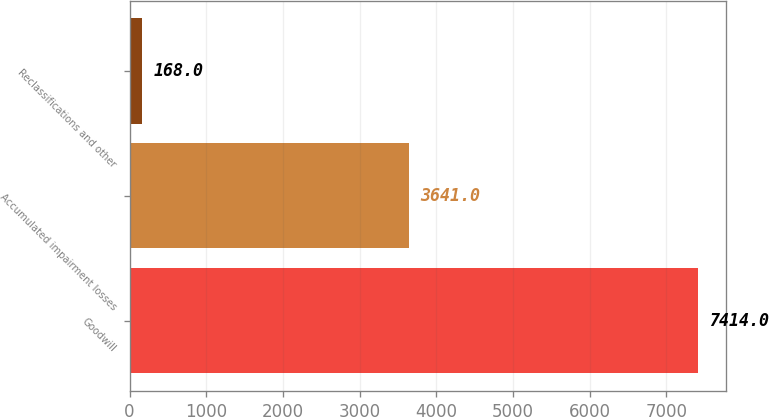Convert chart to OTSL. <chart><loc_0><loc_0><loc_500><loc_500><bar_chart><fcel>Goodwill<fcel>Accumulated impairment losses<fcel>Reclassifications and other<nl><fcel>7414<fcel>3641<fcel>168<nl></chart> 